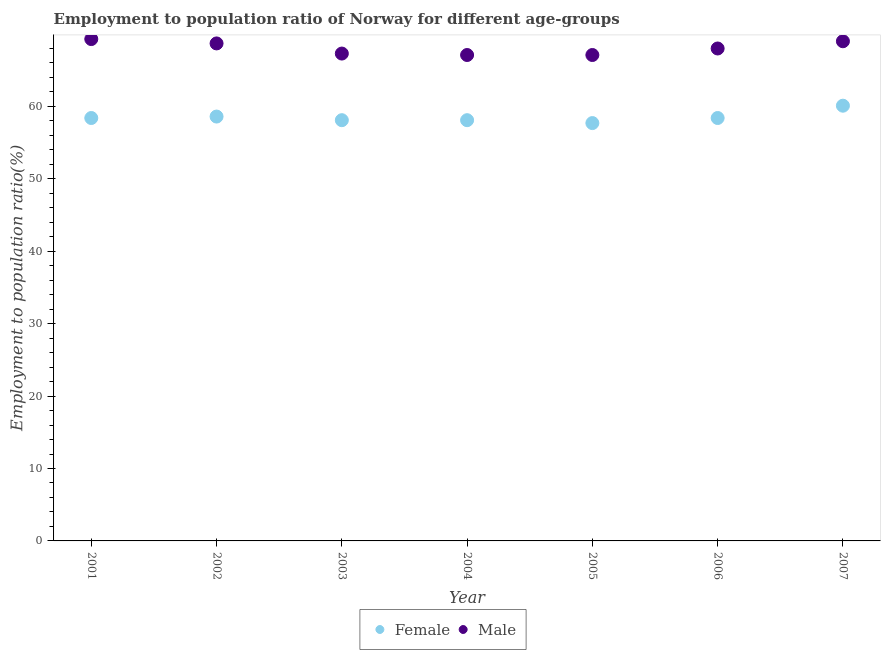How many different coloured dotlines are there?
Give a very brief answer. 2. What is the employment to population ratio(female) in 2007?
Your answer should be compact. 60.1. Across all years, what is the maximum employment to population ratio(male)?
Provide a short and direct response. 69.3. Across all years, what is the minimum employment to population ratio(female)?
Your answer should be compact. 57.7. In which year was the employment to population ratio(male) maximum?
Keep it short and to the point. 2001. In which year was the employment to population ratio(female) minimum?
Make the answer very short. 2005. What is the total employment to population ratio(female) in the graph?
Your response must be concise. 409.4. What is the difference between the employment to population ratio(female) in 2005 and that in 2006?
Ensure brevity in your answer.  -0.7. What is the difference between the employment to population ratio(male) in 2007 and the employment to population ratio(female) in 2001?
Offer a very short reply. 10.6. What is the average employment to population ratio(male) per year?
Provide a succinct answer. 68.07. In the year 2006, what is the difference between the employment to population ratio(female) and employment to population ratio(male)?
Your answer should be compact. -9.6. In how many years, is the employment to population ratio(male) greater than 18 %?
Provide a short and direct response. 7. What is the ratio of the employment to population ratio(female) in 2001 to that in 2004?
Your answer should be compact. 1.01. Is the difference between the employment to population ratio(male) in 2003 and 2007 greater than the difference between the employment to population ratio(female) in 2003 and 2007?
Offer a very short reply. Yes. What is the difference between the highest and the second highest employment to population ratio(female)?
Make the answer very short. 1.5. What is the difference between the highest and the lowest employment to population ratio(male)?
Provide a short and direct response. 2.2. In how many years, is the employment to population ratio(female) greater than the average employment to population ratio(female) taken over all years?
Give a very brief answer. 2. Is the sum of the employment to population ratio(female) in 2001 and 2005 greater than the maximum employment to population ratio(male) across all years?
Your answer should be very brief. Yes. Does the employment to population ratio(male) monotonically increase over the years?
Provide a succinct answer. No. Is the employment to population ratio(female) strictly greater than the employment to population ratio(male) over the years?
Make the answer very short. No. Is the employment to population ratio(male) strictly less than the employment to population ratio(female) over the years?
Your response must be concise. No. Where does the legend appear in the graph?
Offer a terse response. Bottom center. How many legend labels are there?
Provide a short and direct response. 2. What is the title of the graph?
Make the answer very short. Employment to population ratio of Norway for different age-groups. What is the label or title of the Y-axis?
Your answer should be compact. Employment to population ratio(%). What is the Employment to population ratio(%) in Female in 2001?
Give a very brief answer. 58.4. What is the Employment to population ratio(%) in Male in 2001?
Your answer should be very brief. 69.3. What is the Employment to population ratio(%) in Female in 2002?
Ensure brevity in your answer.  58.6. What is the Employment to population ratio(%) of Male in 2002?
Keep it short and to the point. 68.7. What is the Employment to population ratio(%) in Female in 2003?
Ensure brevity in your answer.  58.1. What is the Employment to population ratio(%) of Male in 2003?
Offer a very short reply. 67.3. What is the Employment to population ratio(%) in Female in 2004?
Your answer should be very brief. 58.1. What is the Employment to population ratio(%) in Male in 2004?
Your answer should be compact. 67.1. What is the Employment to population ratio(%) of Female in 2005?
Your answer should be very brief. 57.7. What is the Employment to population ratio(%) of Male in 2005?
Your response must be concise. 67.1. What is the Employment to population ratio(%) of Female in 2006?
Keep it short and to the point. 58.4. What is the Employment to population ratio(%) of Male in 2006?
Keep it short and to the point. 68. What is the Employment to population ratio(%) in Female in 2007?
Your answer should be very brief. 60.1. Across all years, what is the maximum Employment to population ratio(%) of Female?
Your answer should be compact. 60.1. Across all years, what is the maximum Employment to population ratio(%) of Male?
Your response must be concise. 69.3. Across all years, what is the minimum Employment to population ratio(%) in Female?
Make the answer very short. 57.7. Across all years, what is the minimum Employment to population ratio(%) of Male?
Your answer should be very brief. 67.1. What is the total Employment to population ratio(%) of Female in the graph?
Your response must be concise. 409.4. What is the total Employment to population ratio(%) in Male in the graph?
Keep it short and to the point. 476.5. What is the difference between the Employment to population ratio(%) of Female in 2001 and that in 2002?
Your response must be concise. -0.2. What is the difference between the Employment to population ratio(%) of Female in 2001 and that in 2003?
Offer a terse response. 0.3. What is the difference between the Employment to population ratio(%) of Female in 2001 and that in 2004?
Give a very brief answer. 0.3. What is the difference between the Employment to population ratio(%) of Male in 2001 and that in 2004?
Provide a short and direct response. 2.2. What is the difference between the Employment to population ratio(%) in Male in 2001 and that in 2005?
Ensure brevity in your answer.  2.2. What is the difference between the Employment to population ratio(%) in Female in 2001 and that in 2006?
Provide a short and direct response. 0. What is the difference between the Employment to population ratio(%) in Male in 2001 and that in 2006?
Give a very brief answer. 1.3. What is the difference between the Employment to population ratio(%) of Female in 2001 and that in 2007?
Ensure brevity in your answer.  -1.7. What is the difference between the Employment to population ratio(%) of Female in 2002 and that in 2004?
Ensure brevity in your answer.  0.5. What is the difference between the Employment to population ratio(%) in Female in 2002 and that in 2005?
Your answer should be compact. 0.9. What is the difference between the Employment to population ratio(%) of Male in 2002 and that in 2005?
Give a very brief answer. 1.6. What is the difference between the Employment to population ratio(%) of Female in 2002 and that in 2006?
Your answer should be compact. 0.2. What is the difference between the Employment to population ratio(%) in Male in 2002 and that in 2007?
Ensure brevity in your answer.  -0.3. What is the difference between the Employment to population ratio(%) in Female in 2003 and that in 2004?
Your answer should be very brief. 0. What is the difference between the Employment to population ratio(%) in Male in 2003 and that in 2004?
Offer a very short reply. 0.2. What is the difference between the Employment to population ratio(%) of Female in 2003 and that in 2005?
Keep it short and to the point. 0.4. What is the difference between the Employment to population ratio(%) of Female in 2003 and that in 2006?
Keep it short and to the point. -0.3. What is the difference between the Employment to population ratio(%) of Female in 2003 and that in 2007?
Keep it short and to the point. -2. What is the difference between the Employment to population ratio(%) in Male in 2003 and that in 2007?
Your response must be concise. -1.7. What is the difference between the Employment to population ratio(%) in Male in 2004 and that in 2005?
Offer a terse response. 0. What is the difference between the Employment to population ratio(%) in Female in 2004 and that in 2006?
Your answer should be compact. -0.3. What is the difference between the Employment to population ratio(%) of Male in 2004 and that in 2006?
Provide a short and direct response. -0.9. What is the difference between the Employment to population ratio(%) of Female in 2004 and that in 2007?
Offer a very short reply. -2. What is the difference between the Employment to population ratio(%) in Male in 2004 and that in 2007?
Keep it short and to the point. -1.9. What is the difference between the Employment to population ratio(%) in Male in 2005 and that in 2006?
Make the answer very short. -0.9. What is the difference between the Employment to population ratio(%) in Female in 2005 and that in 2007?
Provide a succinct answer. -2.4. What is the difference between the Employment to population ratio(%) in Female in 2001 and the Employment to population ratio(%) in Male in 2007?
Provide a short and direct response. -10.6. What is the difference between the Employment to population ratio(%) in Female in 2002 and the Employment to population ratio(%) in Male in 2003?
Your answer should be very brief. -8.7. What is the difference between the Employment to population ratio(%) in Female in 2002 and the Employment to population ratio(%) in Male in 2006?
Offer a very short reply. -9.4. What is the difference between the Employment to population ratio(%) of Female in 2003 and the Employment to population ratio(%) of Male in 2004?
Keep it short and to the point. -9. What is the average Employment to population ratio(%) in Female per year?
Your answer should be very brief. 58.49. What is the average Employment to population ratio(%) in Male per year?
Make the answer very short. 68.07. In the year 2001, what is the difference between the Employment to population ratio(%) of Female and Employment to population ratio(%) of Male?
Give a very brief answer. -10.9. In the year 2003, what is the difference between the Employment to population ratio(%) in Female and Employment to population ratio(%) in Male?
Offer a very short reply. -9.2. In the year 2006, what is the difference between the Employment to population ratio(%) in Female and Employment to population ratio(%) in Male?
Make the answer very short. -9.6. In the year 2007, what is the difference between the Employment to population ratio(%) of Female and Employment to population ratio(%) of Male?
Your response must be concise. -8.9. What is the ratio of the Employment to population ratio(%) of Male in 2001 to that in 2002?
Offer a very short reply. 1.01. What is the ratio of the Employment to population ratio(%) of Male in 2001 to that in 2003?
Keep it short and to the point. 1.03. What is the ratio of the Employment to population ratio(%) in Female in 2001 to that in 2004?
Offer a terse response. 1.01. What is the ratio of the Employment to population ratio(%) in Male in 2001 to that in 2004?
Ensure brevity in your answer.  1.03. What is the ratio of the Employment to population ratio(%) in Female in 2001 to that in 2005?
Ensure brevity in your answer.  1.01. What is the ratio of the Employment to population ratio(%) of Male in 2001 to that in 2005?
Offer a very short reply. 1.03. What is the ratio of the Employment to population ratio(%) in Female in 2001 to that in 2006?
Provide a short and direct response. 1. What is the ratio of the Employment to population ratio(%) in Male in 2001 to that in 2006?
Give a very brief answer. 1.02. What is the ratio of the Employment to population ratio(%) in Female in 2001 to that in 2007?
Keep it short and to the point. 0.97. What is the ratio of the Employment to population ratio(%) in Male in 2001 to that in 2007?
Your answer should be compact. 1. What is the ratio of the Employment to population ratio(%) in Female in 2002 to that in 2003?
Provide a succinct answer. 1.01. What is the ratio of the Employment to population ratio(%) in Male in 2002 to that in 2003?
Make the answer very short. 1.02. What is the ratio of the Employment to population ratio(%) of Female in 2002 to that in 2004?
Your response must be concise. 1.01. What is the ratio of the Employment to population ratio(%) in Male in 2002 to that in 2004?
Your answer should be compact. 1.02. What is the ratio of the Employment to population ratio(%) of Female in 2002 to that in 2005?
Offer a very short reply. 1.02. What is the ratio of the Employment to population ratio(%) in Male in 2002 to that in 2005?
Provide a succinct answer. 1.02. What is the ratio of the Employment to population ratio(%) in Male in 2002 to that in 2006?
Provide a succinct answer. 1.01. What is the ratio of the Employment to population ratio(%) of Female in 2002 to that in 2007?
Offer a very short reply. 0.97. What is the ratio of the Employment to population ratio(%) in Female in 2003 to that in 2004?
Your answer should be very brief. 1. What is the ratio of the Employment to population ratio(%) of Male in 2003 to that in 2004?
Your response must be concise. 1. What is the ratio of the Employment to population ratio(%) in Male in 2003 to that in 2005?
Your answer should be very brief. 1. What is the ratio of the Employment to population ratio(%) of Female in 2003 to that in 2006?
Provide a succinct answer. 0.99. What is the ratio of the Employment to population ratio(%) in Male in 2003 to that in 2006?
Keep it short and to the point. 0.99. What is the ratio of the Employment to population ratio(%) in Female in 2003 to that in 2007?
Your response must be concise. 0.97. What is the ratio of the Employment to population ratio(%) in Male in 2003 to that in 2007?
Keep it short and to the point. 0.98. What is the ratio of the Employment to population ratio(%) in Female in 2004 to that in 2005?
Offer a terse response. 1.01. What is the ratio of the Employment to population ratio(%) in Male in 2004 to that in 2005?
Provide a succinct answer. 1. What is the ratio of the Employment to population ratio(%) of Female in 2004 to that in 2006?
Offer a terse response. 0.99. What is the ratio of the Employment to population ratio(%) of Female in 2004 to that in 2007?
Make the answer very short. 0.97. What is the ratio of the Employment to population ratio(%) in Male in 2004 to that in 2007?
Make the answer very short. 0.97. What is the ratio of the Employment to population ratio(%) in Female in 2005 to that in 2006?
Offer a terse response. 0.99. What is the ratio of the Employment to population ratio(%) of Female in 2005 to that in 2007?
Offer a very short reply. 0.96. What is the ratio of the Employment to population ratio(%) in Male in 2005 to that in 2007?
Ensure brevity in your answer.  0.97. What is the ratio of the Employment to population ratio(%) in Female in 2006 to that in 2007?
Your response must be concise. 0.97. What is the ratio of the Employment to population ratio(%) of Male in 2006 to that in 2007?
Provide a short and direct response. 0.99. What is the difference between the highest and the second highest Employment to population ratio(%) in Male?
Provide a succinct answer. 0.3. What is the difference between the highest and the lowest Employment to population ratio(%) of Male?
Provide a succinct answer. 2.2. 